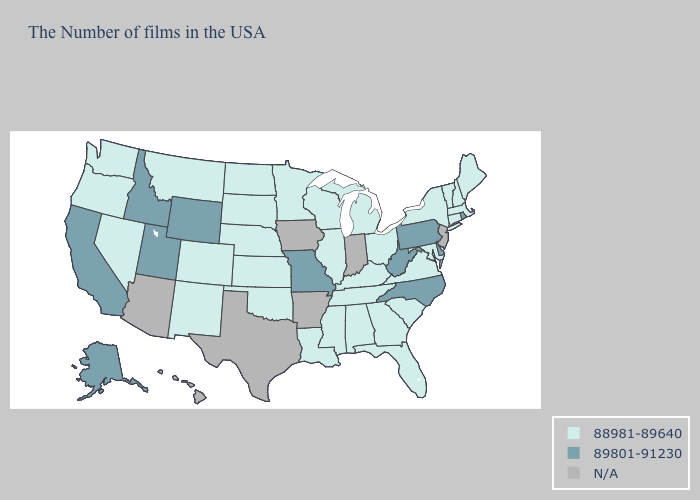Which states have the highest value in the USA?
Be succinct. Rhode Island, Delaware, Pennsylvania, North Carolina, West Virginia, Missouri, Wyoming, Utah, Idaho, California, Alaska. Does Pennsylvania have the lowest value in the USA?
Quick response, please. No. Name the states that have a value in the range 89801-91230?
Short answer required. Rhode Island, Delaware, Pennsylvania, North Carolina, West Virginia, Missouri, Wyoming, Utah, Idaho, California, Alaska. What is the lowest value in the MidWest?
Quick response, please. 88981-89640. How many symbols are there in the legend?
Short answer required. 3. What is the value of California?
Give a very brief answer. 89801-91230. Which states have the highest value in the USA?
Write a very short answer. Rhode Island, Delaware, Pennsylvania, North Carolina, West Virginia, Missouri, Wyoming, Utah, Idaho, California, Alaska. Does Pennsylvania have the lowest value in the USA?
Answer briefly. No. Name the states that have a value in the range N/A?
Write a very short answer. New Jersey, Indiana, Arkansas, Iowa, Texas, Arizona, Hawaii. Name the states that have a value in the range 89801-91230?
Be succinct. Rhode Island, Delaware, Pennsylvania, North Carolina, West Virginia, Missouri, Wyoming, Utah, Idaho, California, Alaska. Name the states that have a value in the range N/A?
Concise answer only. New Jersey, Indiana, Arkansas, Iowa, Texas, Arizona, Hawaii. Which states have the lowest value in the USA?
Concise answer only. Maine, Massachusetts, New Hampshire, Vermont, Connecticut, New York, Maryland, Virginia, South Carolina, Ohio, Florida, Georgia, Michigan, Kentucky, Alabama, Tennessee, Wisconsin, Illinois, Mississippi, Louisiana, Minnesota, Kansas, Nebraska, Oklahoma, South Dakota, North Dakota, Colorado, New Mexico, Montana, Nevada, Washington, Oregon. What is the highest value in the Northeast ?
Short answer required. 89801-91230. How many symbols are there in the legend?
Keep it brief. 3. 